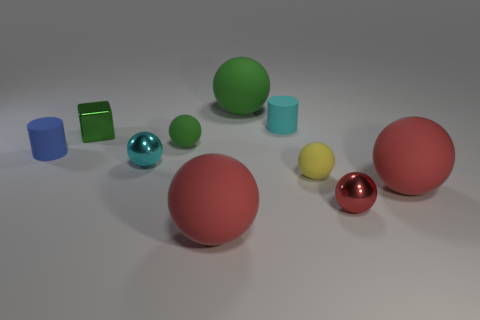Are there more small metal things that are in front of the green metallic block than big matte things behind the small yellow rubber object?
Offer a very short reply. Yes. What shape is the cyan rubber object?
Keep it short and to the point. Cylinder. Is the material of the big red thing behind the small red metallic thing the same as the big thing that is behind the small yellow ball?
Ensure brevity in your answer.  Yes. There is a metallic object behind the small green matte ball; what is its shape?
Your response must be concise. Cube. What size is the cyan thing that is the same shape as the large green rubber object?
Offer a terse response. Small. Are there any other things that have the same shape as the green metallic object?
Provide a short and direct response. No. There is a rubber cylinder that is left of the tiny metallic block; are there any tiny matte balls in front of it?
Keep it short and to the point. Yes. There is another tiny matte object that is the same shape as the blue object; what is its color?
Ensure brevity in your answer.  Cyan. What number of other metal blocks are the same color as the shiny block?
Make the answer very short. 0. What is the color of the cylinder on the right side of the big matte object in front of the large red rubber ball that is to the right of the large green object?
Your answer should be compact. Cyan. 